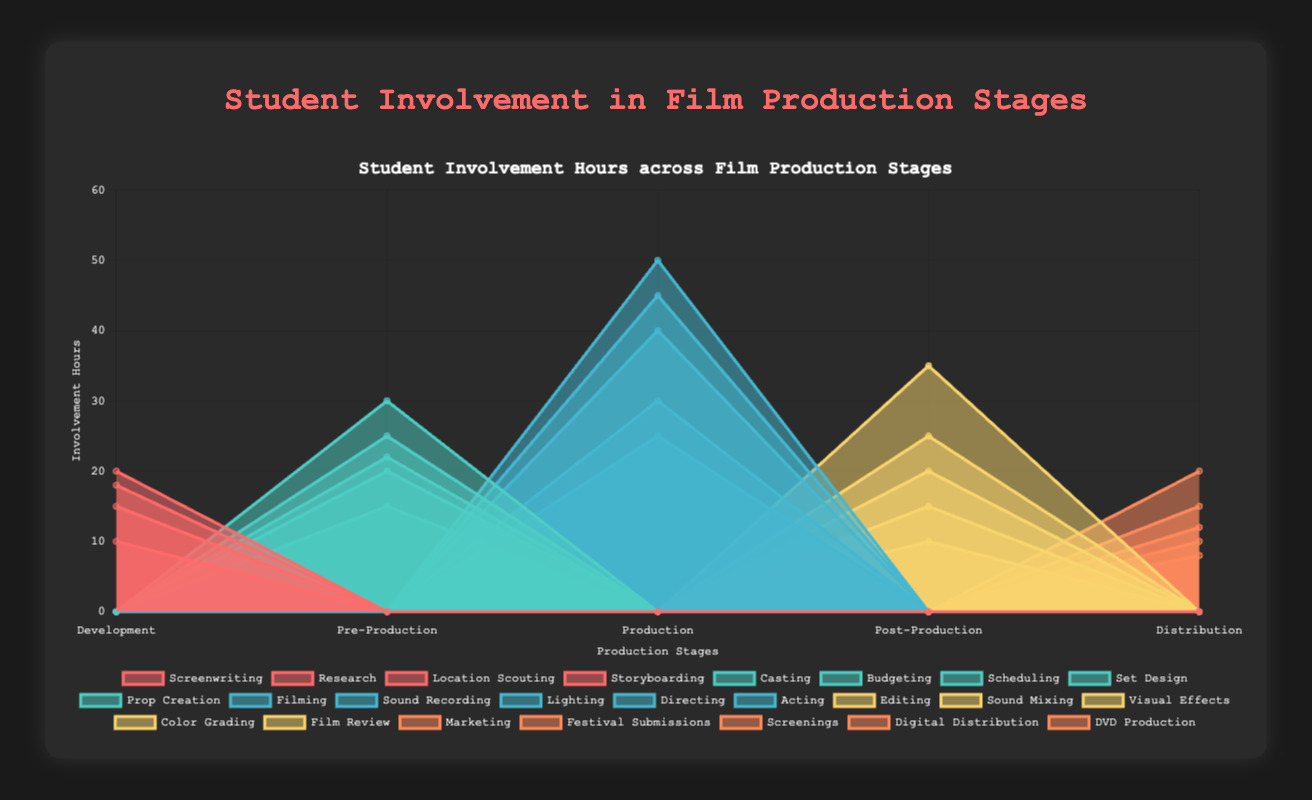What are the five stages of film production represented in the chart? The chart categorizes the student involvement hours across five stages of film production. These stages are visibly labeled on the X-axis of the chart.
Answer: Development, Pre-Production, Production, Post-Production, Distribution Which stage involved the most student hours in Filming? By observing the dataset representing Filming, it reaches its peak during the Production stage, visually depicted by the height of the area corresponding to Filming's dataset at the Production stage on the X-axis.
Answer: Production How many hours did students spend on Set Design during Pre-Production? The area segment representing Set Design under the Pre-Production stage reaches up to 30 on the Y-axis.
Answer: 30 Compare student hours spent on Editing and Marketing. Which one was higher and by how much? Editing occurs in Post-Production and reaches 35 hours, while Marketing occurs in Distribution and reaches 20 hours. Thus, Editing involved 35 - 20 = 15 hours more than Marketing.
Answer: Editing by 15 hours What is the title of the area chart? The title of the chart is prominently displayed at the top of the chart and provides a summary of the visual data.
Answer: Student Involvement in Film Production Stages What is the total number of student hours spent during the Distribution stage? To find this, add up the student involvement hours for Marketing (20), Festival Submissions (15), Screenings (10), Digital Distribution (12), and DVD Production (8). The sum is 20 + 15 + 10 + 12 + 8 = 65.
Answer: 65 How do student involvement hours in Acting compare to those in Directing during the Production stage? Within the Production stage, the hours for Acting are 45 and for Directing are 40, making Acting greater by 5 hours.
Answer: Acting by 5 hours Which stage has the lowest cumulative student involvement hours? Summing the involvement hours per stage shows Distribution with Marketing (20), Festival Submissions (15), Screenings (10), Digital Distribution (12), and DVD Production (8) totaling 65 hours. This total is lower than the sums of other stages.
Answer: Distribution What are some activities students are involved in during Pre-Production? By viewing the different areas within the Pre-Production stage, students are involved in Casting, Budgeting, Scheduling, Set Design, and Prop Creation, as indicated by the chart segments and labels.
Answer: Casting, Budgeting, Scheduling, Set Design, Prop Creation 